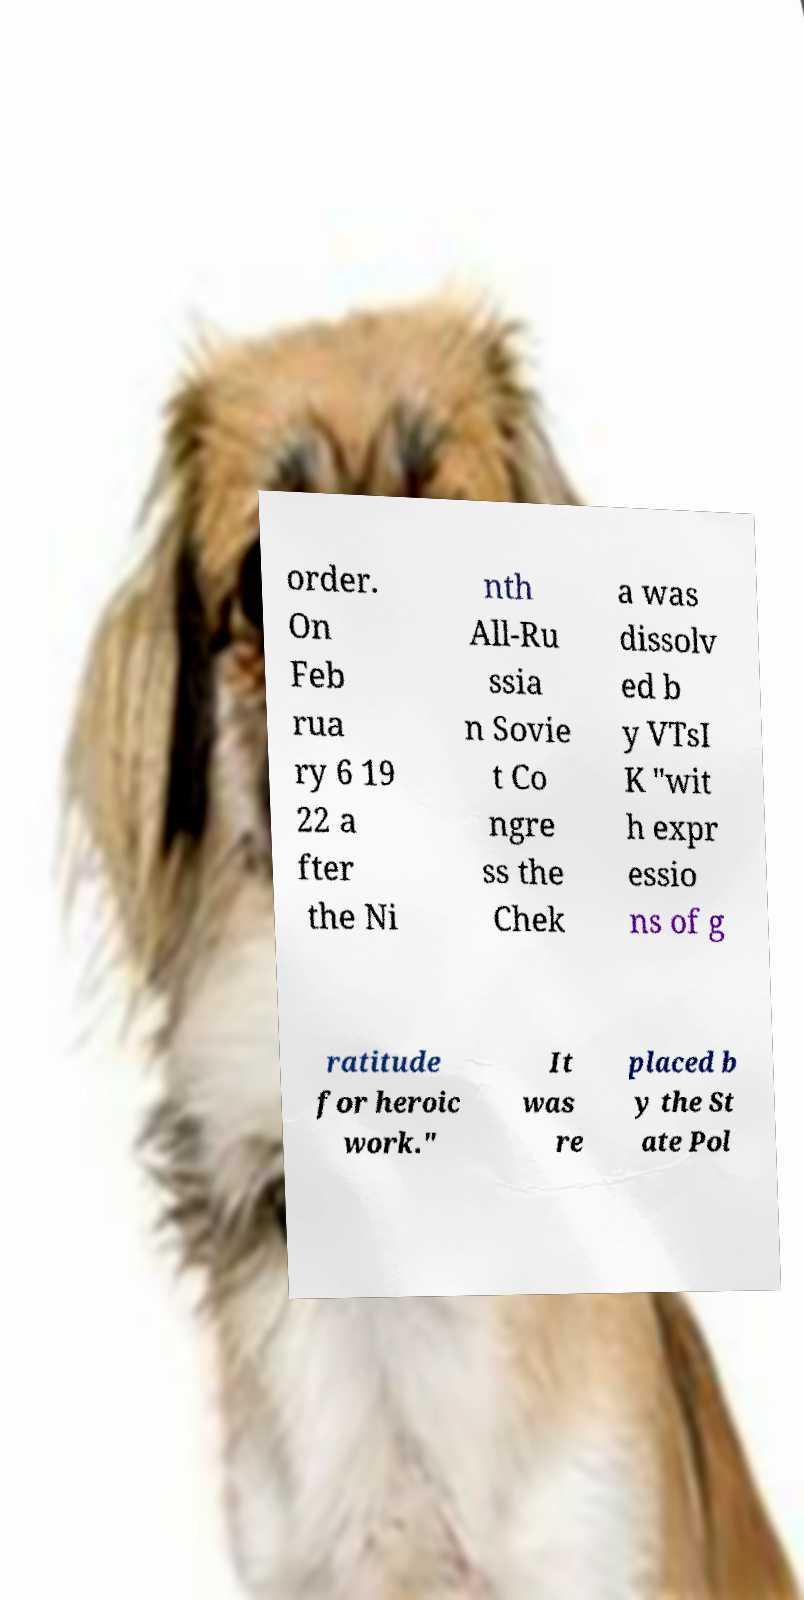What messages or text are displayed in this image? I need them in a readable, typed format. order. On Feb rua ry 6 19 22 a fter the Ni nth All-Ru ssia n Sovie t Co ngre ss the Chek a was dissolv ed b y VTsI K "wit h expr essio ns of g ratitude for heroic work." It was re placed b y the St ate Pol 